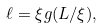<formula> <loc_0><loc_0><loc_500><loc_500>\ell = \xi g ( L / \xi ) ,</formula> 